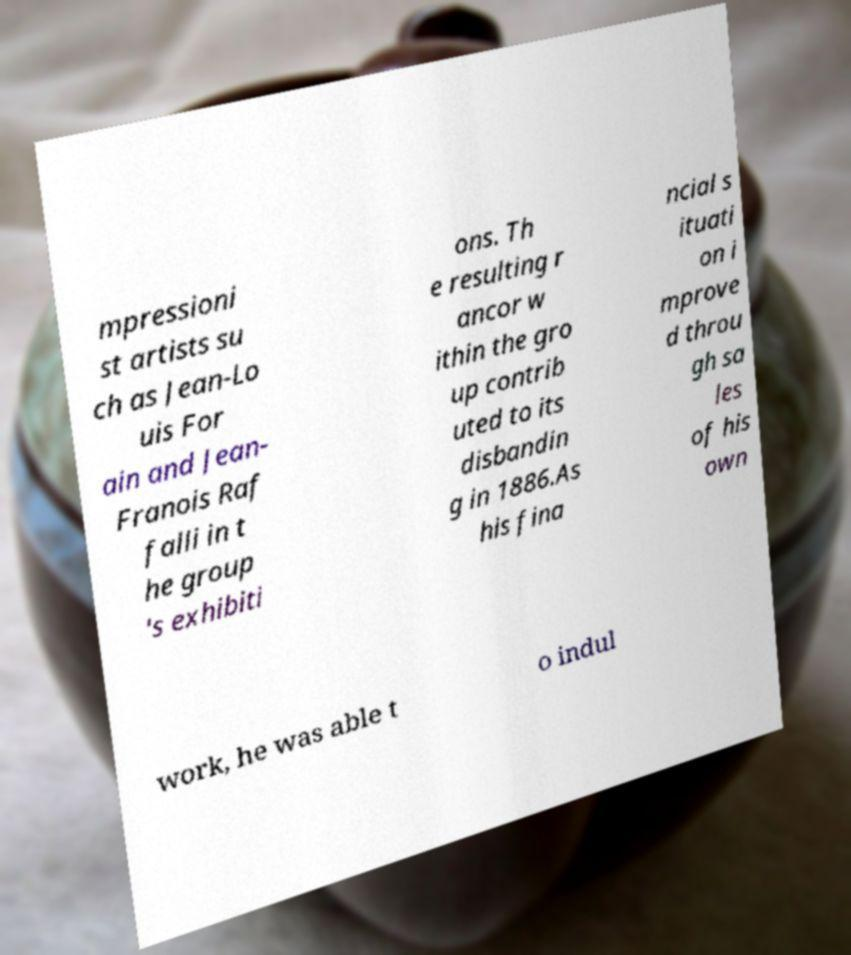Could you extract and type out the text from this image? mpressioni st artists su ch as Jean-Lo uis For ain and Jean- Franois Raf falli in t he group 's exhibiti ons. Th e resulting r ancor w ithin the gro up contrib uted to its disbandin g in 1886.As his fina ncial s ituati on i mprove d throu gh sa les of his own work, he was able t o indul 